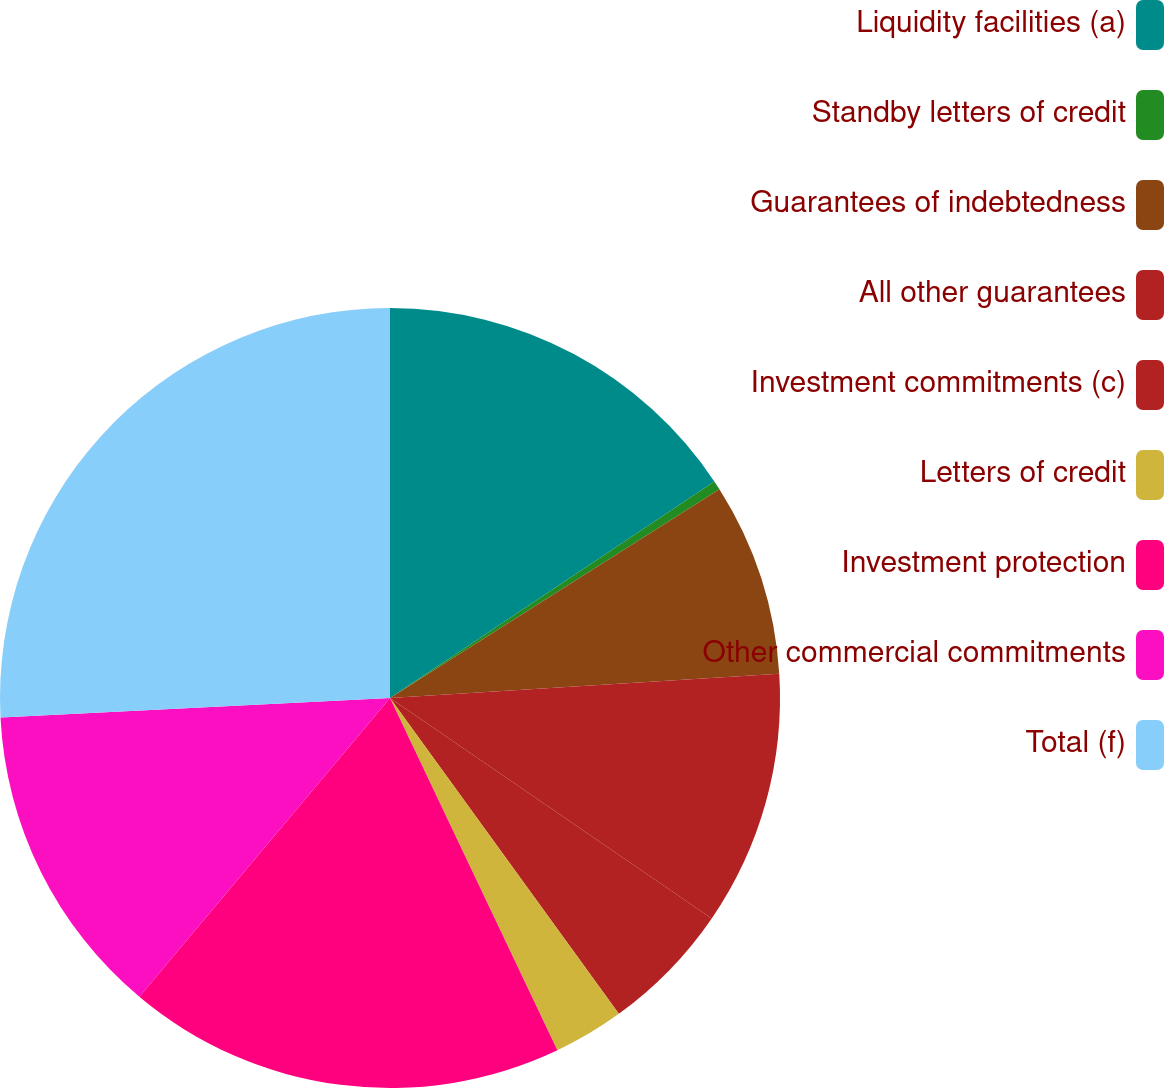Convert chart to OTSL. <chart><loc_0><loc_0><loc_500><loc_500><pie_chart><fcel>Liquidity facilities (a)<fcel>Standby letters of credit<fcel>Guarantees of indebtedness<fcel>All other guarantees<fcel>Investment commitments (c)<fcel>Letters of credit<fcel>Investment protection<fcel>Other commercial commitments<fcel>Total (f)<nl><fcel>15.63%<fcel>0.38%<fcel>8.0%<fcel>10.55%<fcel>5.46%<fcel>2.92%<fcel>18.17%<fcel>13.09%<fcel>25.8%<nl></chart> 